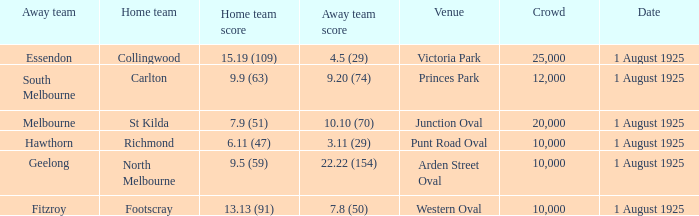When did the match take place that had a home team score of 7.9 (51)? 1 August 1925. 